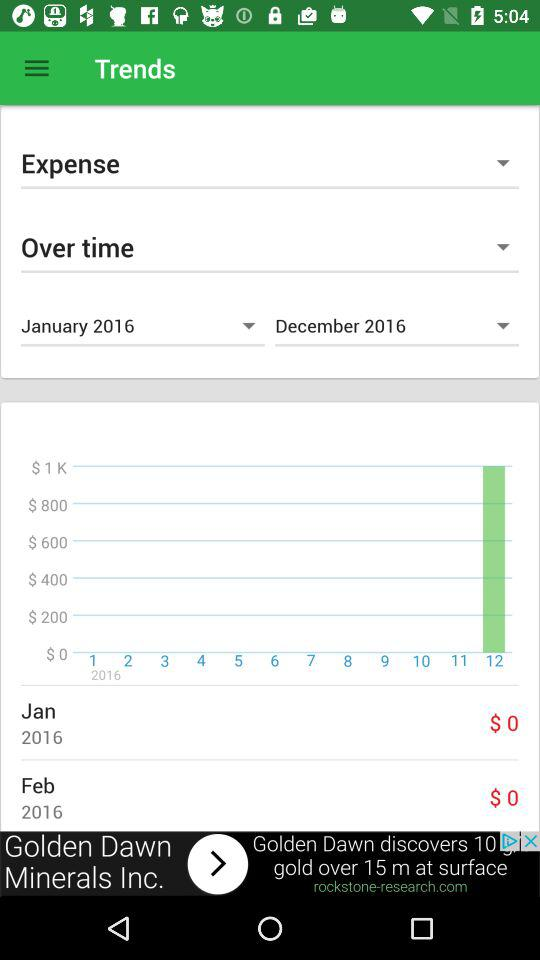How many months are represented in the graph?
Answer the question using a single word or phrase. 12 